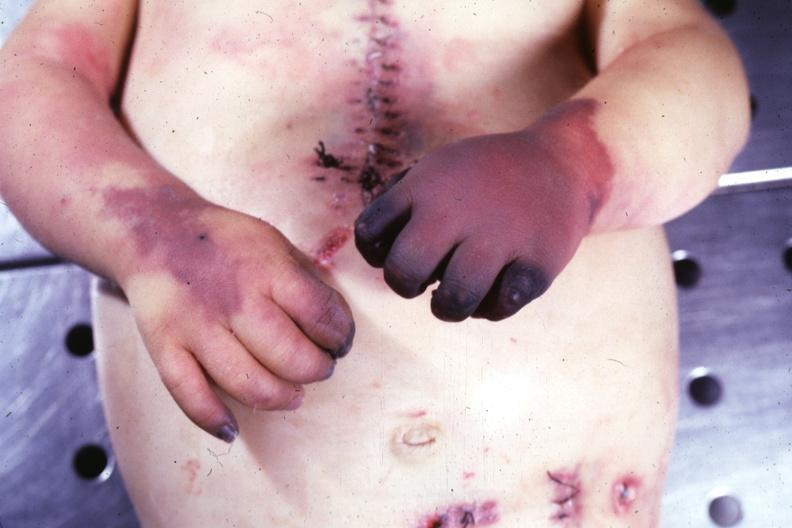how does this image show gangrene both hands due to embolism case of av canal?
Answer the question using a single word or phrase. With downs syndrome 